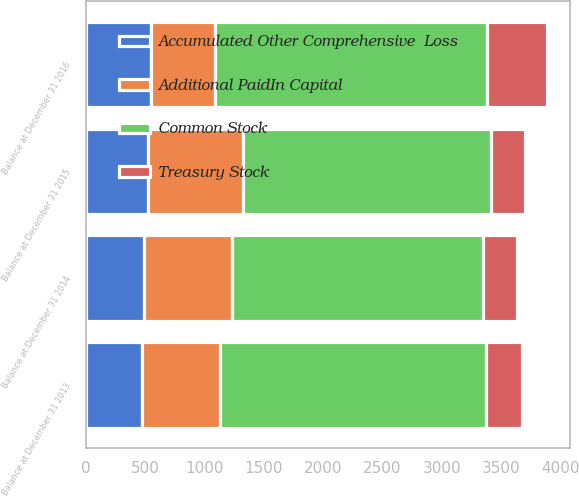Convert chart to OTSL. <chart><loc_0><loc_0><loc_500><loc_500><stacked_bar_chart><ecel><fcel>Balance at December 31 2013<fcel>Balance at December 31 2014<fcel>Balance at December 31 2015<fcel>Balance at December 31 2016<nl><fcel>Treasury Stock<fcel>297.5<fcel>288.7<fcel>287.5<fcel>504.8<nl><fcel>Accumulated Other Comprehensive  Loss<fcel>477.2<fcel>493.1<fcel>523.1<fcel>545.3<nl><fcel>Additional PaidIn Capital<fcel>654.3<fcel>739<fcel>801.4<fcel>545.3<nl><fcel>Common Stock<fcel>2242.1<fcel>2111.2<fcel>2090.9<fcel>2289.9<nl></chart> 